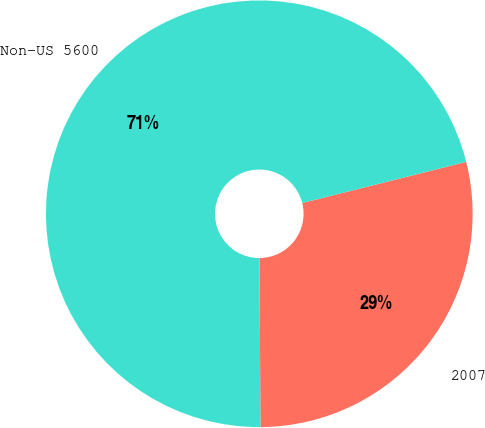<chart> <loc_0><loc_0><loc_500><loc_500><pie_chart><fcel>2007<fcel>Non-US 5600<nl><fcel>28.83%<fcel>71.17%<nl></chart> 